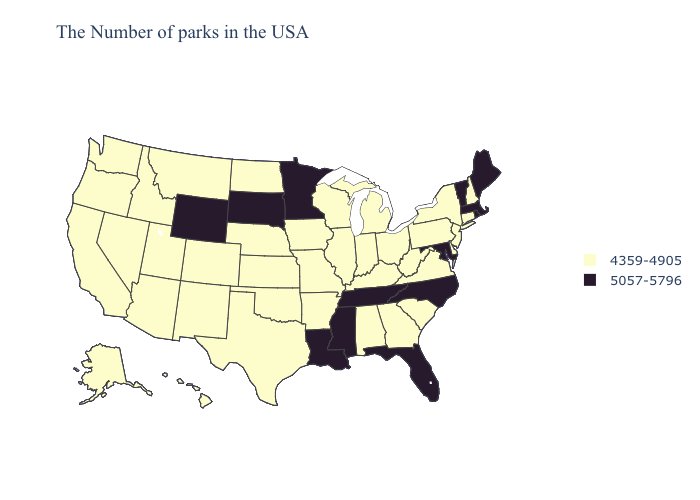What is the value of Illinois?
Give a very brief answer. 4359-4905. What is the highest value in the Northeast ?
Answer briefly. 5057-5796. How many symbols are there in the legend?
Give a very brief answer. 2. Name the states that have a value in the range 5057-5796?
Give a very brief answer. Maine, Massachusetts, Rhode Island, Vermont, Maryland, North Carolina, Florida, Tennessee, Mississippi, Louisiana, Minnesota, South Dakota, Wyoming. What is the highest value in states that border Colorado?
Keep it brief. 5057-5796. Among the states that border New York , which have the lowest value?
Quick response, please. Connecticut, New Jersey, Pennsylvania. Name the states that have a value in the range 4359-4905?
Be succinct. New Hampshire, Connecticut, New York, New Jersey, Delaware, Pennsylvania, Virginia, South Carolina, West Virginia, Ohio, Georgia, Michigan, Kentucky, Indiana, Alabama, Wisconsin, Illinois, Missouri, Arkansas, Iowa, Kansas, Nebraska, Oklahoma, Texas, North Dakota, Colorado, New Mexico, Utah, Montana, Arizona, Idaho, Nevada, California, Washington, Oregon, Alaska, Hawaii. What is the lowest value in states that border Indiana?
Short answer required. 4359-4905. Name the states that have a value in the range 5057-5796?
Give a very brief answer. Maine, Massachusetts, Rhode Island, Vermont, Maryland, North Carolina, Florida, Tennessee, Mississippi, Louisiana, Minnesota, South Dakota, Wyoming. Does California have the lowest value in the West?
Answer briefly. Yes. Name the states that have a value in the range 5057-5796?
Keep it brief. Maine, Massachusetts, Rhode Island, Vermont, Maryland, North Carolina, Florida, Tennessee, Mississippi, Louisiana, Minnesota, South Dakota, Wyoming. How many symbols are there in the legend?
Be succinct. 2. Does South Dakota have the lowest value in the USA?
Keep it brief. No. Does Vermont have the lowest value in the Northeast?
Quick response, please. No. 